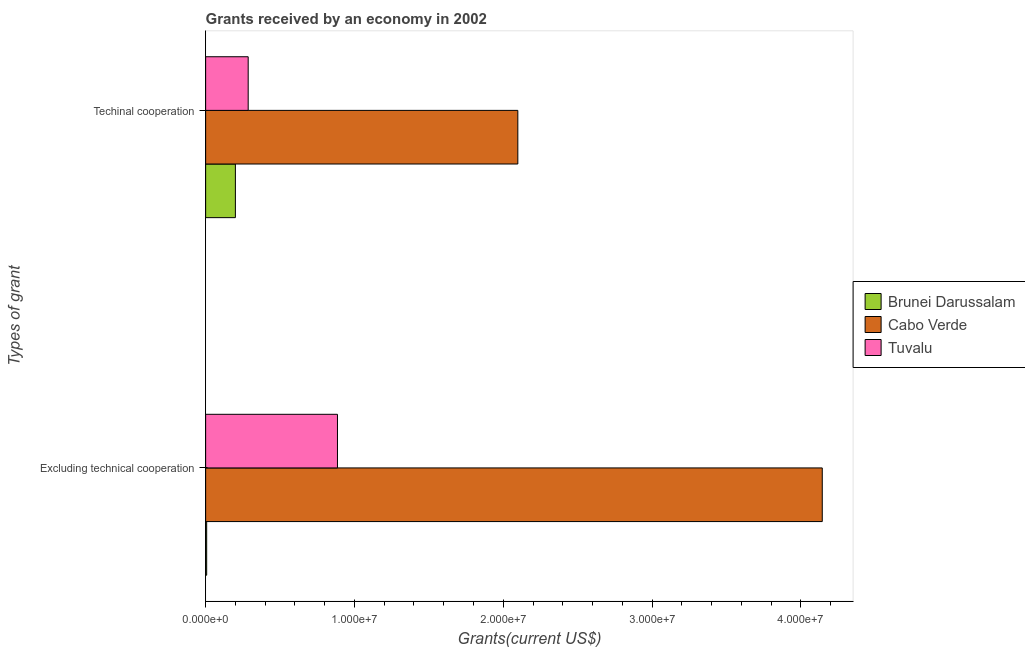How many different coloured bars are there?
Make the answer very short. 3. Are the number of bars per tick equal to the number of legend labels?
Offer a very short reply. Yes. Are the number of bars on each tick of the Y-axis equal?
Keep it short and to the point. Yes. What is the label of the 2nd group of bars from the top?
Keep it short and to the point. Excluding technical cooperation. What is the amount of grants received(excluding technical cooperation) in Cabo Verde?
Keep it short and to the point. 4.14e+07. Across all countries, what is the maximum amount of grants received(including technical cooperation)?
Provide a short and direct response. 2.10e+07. Across all countries, what is the minimum amount of grants received(excluding technical cooperation)?
Keep it short and to the point. 7.00e+04. In which country was the amount of grants received(excluding technical cooperation) maximum?
Offer a very short reply. Cabo Verde. In which country was the amount of grants received(excluding technical cooperation) minimum?
Your answer should be compact. Brunei Darussalam. What is the total amount of grants received(excluding technical cooperation) in the graph?
Your answer should be very brief. 5.04e+07. What is the difference between the amount of grants received(excluding technical cooperation) in Cabo Verde and that in Brunei Darussalam?
Give a very brief answer. 4.14e+07. What is the difference between the amount of grants received(including technical cooperation) in Tuvalu and the amount of grants received(excluding technical cooperation) in Cabo Verde?
Your answer should be compact. -3.86e+07. What is the average amount of grants received(including technical cooperation) per country?
Offer a terse response. 8.61e+06. In how many countries, is the amount of grants received(excluding technical cooperation) greater than 20000000 US$?
Ensure brevity in your answer.  1. What is the ratio of the amount of grants received(including technical cooperation) in Brunei Darussalam to that in Tuvalu?
Keep it short and to the point. 0.7. Is the amount of grants received(including technical cooperation) in Brunei Darussalam less than that in Cabo Verde?
Offer a very short reply. Yes. What does the 3rd bar from the top in Excluding technical cooperation represents?
Provide a succinct answer. Brunei Darussalam. What does the 3rd bar from the bottom in Techinal cooperation represents?
Ensure brevity in your answer.  Tuvalu. What is the difference between two consecutive major ticks on the X-axis?
Ensure brevity in your answer.  1.00e+07. Does the graph contain any zero values?
Your answer should be compact. No. Does the graph contain grids?
Your answer should be compact. No. Where does the legend appear in the graph?
Offer a terse response. Center right. How many legend labels are there?
Provide a succinct answer. 3. How are the legend labels stacked?
Your answer should be compact. Vertical. What is the title of the graph?
Your response must be concise. Grants received by an economy in 2002. Does "Kenya" appear as one of the legend labels in the graph?
Ensure brevity in your answer.  No. What is the label or title of the X-axis?
Ensure brevity in your answer.  Grants(current US$). What is the label or title of the Y-axis?
Provide a succinct answer. Types of grant. What is the Grants(current US$) in Brunei Darussalam in Excluding technical cooperation?
Your response must be concise. 7.00e+04. What is the Grants(current US$) of Cabo Verde in Excluding technical cooperation?
Give a very brief answer. 4.14e+07. What is the Grants(current US$) in Tuvalu in Excluding technical cooperation?
Your answer should be compact. 8.86e+06. What is the Grants(current US$) in Brunei Darussalam in Techinal cooperation?
Your response must be concise. 2.00e+06. What is the Grants(current US$) in Cabo Verde in Techinal cooperation?
Your answer should be very brief. 2.10e+07. What is the Grants(current US$) of Tuvalu in Techinal cooperation?
Provide a succinct answer. 2.86e+06. Across all Types of grant, what is the maximum Grants(current US$) of Cabo Verde?
Your response must be concise. 4.14e+07. Across all Types of grant, what is the maximum Grants(current US$) of Tuvalu?
Your response must be concise. 8.86e+06. Across all Types of grant, what is the minimum Grants(current US$) of Brunei Darussalam?
Ensure brevity in your answer.  7.00e+04. Across all Types of grant, what is the minimum Grants(current US$) of Cabo Verde?
Keep it short and to the point. 2.10e+07. Across all Types of grant, what is the minimum Grants(current US$) in Tuvalu?
Offer a very short reply. 2.86e+06. What is the total Grants(current US$) of Brunei Darussalam in the graph?
Your response must be concise. 2.07e+06. What is the total Grants(current US$) in Cabo Verde in the graph?
Offer a terse response. 6.24e+07. What is the total Grants(current US$) of Tuvalu in the graph?
Your answer should be very brief. 1.17e+07. What is the difference between the Grants(current US$) in Brunei Darussalam in Excluding technical cooperation and that in Techinal cooperation?
Your response must be concise. -1.93e+06. What is the difference between the Grants(current US$) in Cabo Verde in Excluding technical cooperation and that in Techinal cooperation?
Make the answer very short. 2.05e+07. What is the difference between the Grants(current US$) of Brunei Darussalam in Excluding technical cooperation and the Grants(current US$) of Cabo Verde in Techinal cooperation?
Your response must be concise. -2.09e+07. What is the difference between the Grants(current US$) of Brunei Darussalam in Excluding technical cooperation and the Grants(current US$) of Tuvalu in Techinal cooperation?
Offer a terse response. -2.79e+06. What is the difference between the Grants(current US$) in Cabo Verde in Excluding technical cooperation and the Grants(current US$) in Tuvalu in Techinal cooperation?
Keep it short and to the point. 3.86e+07. What is the average Grants(current US$) of Brunei Darussalam per Types of grant?
Keep it short and to the point. 1.04e+06. What is the average Grants(current US$) in Cabo Verde per Types of grant?
Provide a succinct answer. 3.12e+07. What is the average Grants(current US$) of Tuvalu per Types of grant?
Your answer should be very brief. 5.86e+06. What is the difference between the Grants(current US$) in Brunei Darussalam and Grants(current US$) in Cabo Verde in Excluding technical cooperation?
Your response must be concise. -4.14e+07. What is the difference between the Grants(current US$) in Brunei Darussalam and Grants(current US$) in Tuvalu in Excluding technical cooperation?
Ensure brevity in your answer.  -8.79e+06. What is the difference between the Grants(current US$) in Cabo Verde and Grants(current US$) in Tuvalu in Excluding technical cooperation?
Your answer should be very brief. 3.26e+07. What is the difference between the Grants(current US$) of Brunei Darussalam and Grants(current US$) of Cabo Verde in Techinal cooperation?
Provide a short and direct response. -1.90e+07. What is the difference between the Grants(current US$) in Brunei Darussalam and Grants(current US$) in Tuvalu in Techinal cooperation?
Make the answer very short. -8.60e+05. What is the difference between the Grants(current US$) in Cabo Verde and Grants(current US$) in Tuvalu in Techinal cooperation?
Your answer should be compact. 1.81e+07. What is the ratio of the Grants(current US$) in Brunei Darussalam in Excluding technical cooperation to that in Techinal cooperation?
Make the answer very short. 0.04. What is the ratio of the Grants(current US$) in Cabo Verde in Excluding technical cooperation to that in Techinal cooperation?
Keep it short and to the point. 1.98. What is the ratio of the Grants(current US$) in Tuvalu in Excluding technical cooperation to that in Techinal cooperation?
Provide a succinct answer. 3.1. What is the difference between the highest and the second highest Grants(current US$) of Brunei Darussalam?
Give a very brief answer. 1.93e+06. What is the difference between the highest and the second highest Grants(current US$) of Cabo Verde?
Your response must be concise. 2.05e+07. What is the difference between the highest and the lowest Grants(current US$) of Brunei Darussalam?
Your response must be concise. 1.93e+06. What is the difference between the highest and the lowest Grants(current US$) in Cabo Verde?
Make the answer very short. 2.05e+07. 